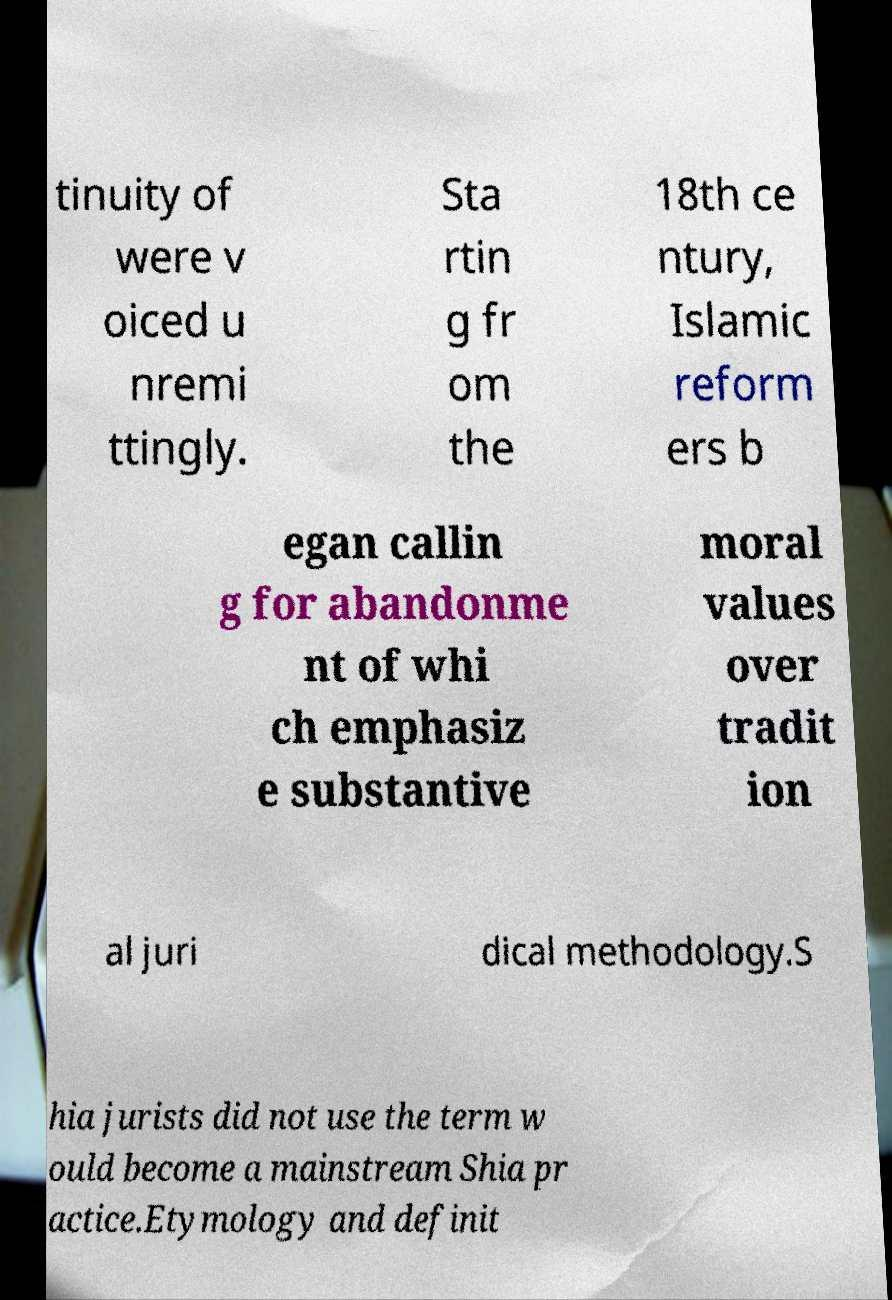Could you extract and type out the text from this image? tinuity of were v oiced u nremi ttingly. Sta rtin g fr om the 18th ce ntury, Islamic reform ers b egan callin g for abandonme nt of whi ch emphasiz e substantive moral values over tradit ion al juri dical methodology.S hia jurists did not use the term w ould become a mainstream Shia pr actice.Etymology and definit 